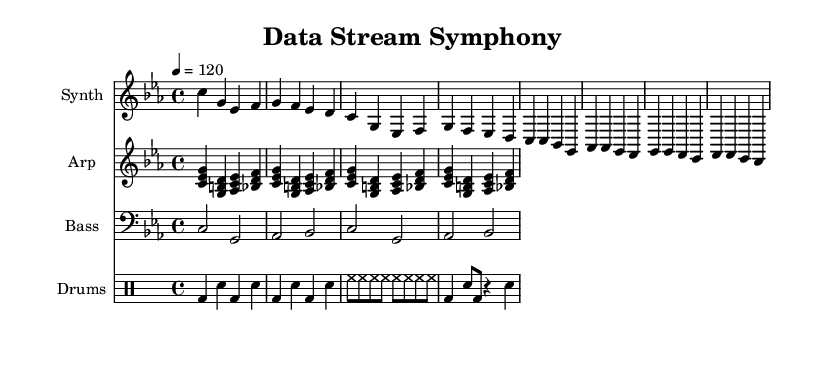What is the key signature of this music? The key signature is C minor, which has three flats (B♭, E♭, and A♭). This can be seen at the beginning of the staff, where the flat symbols are placed.
Answer: C minor What is the time signature of this music? The time signature is 4/4 as indicated at the beginning of the score. This means there are four beats in a measure and the quarter note gets one beat.
Answer: 4/4 What is the tempo marking? The tempo marking is indicated as "4 = 120", which means that there are 120 beats per minute and each beat corresponds to a quarter note. This can be found in the tempo indication at the beginning of the score.
Answer: 120 How many measures are there in the synth part? By counting the distinct groups of notes and bar lines in the synth part, we find that there are 8 measures in total.
Answer: 8 What type of instruments are shown in this score? The score shows a Synth, an Arpeggiator ("Arp"), a Bass, and Drums as indicated by the instrument names above each staff.
Answer: Synth, Arp, Bass, Drums What rhythmic pattern is used in the drum section? The drum section shows a combination of bass drum (bd), snare (sn), and hi-hat (hh) patterns, with specific notes on given beats, indicating a typical electronic dance rhythm.
Answer: Electronic dance rhythm How does the bass line relate to the synth melody? The bass line outlines the root notes that correspond with the melody in the synth part, providing harmonic support; both parts work together to create a cohesive sound common in electronic music compositions.
Answer: Harmonic support 